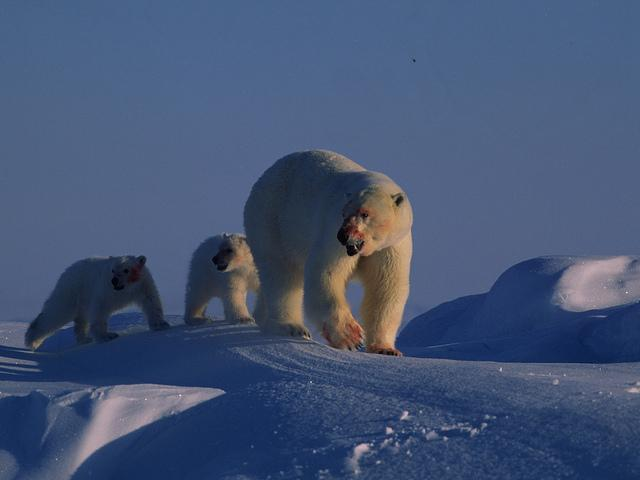Red on this bears face comes from it's what?

Choices:
A) tail
B) prey
C) sunburn
D) cub prey 